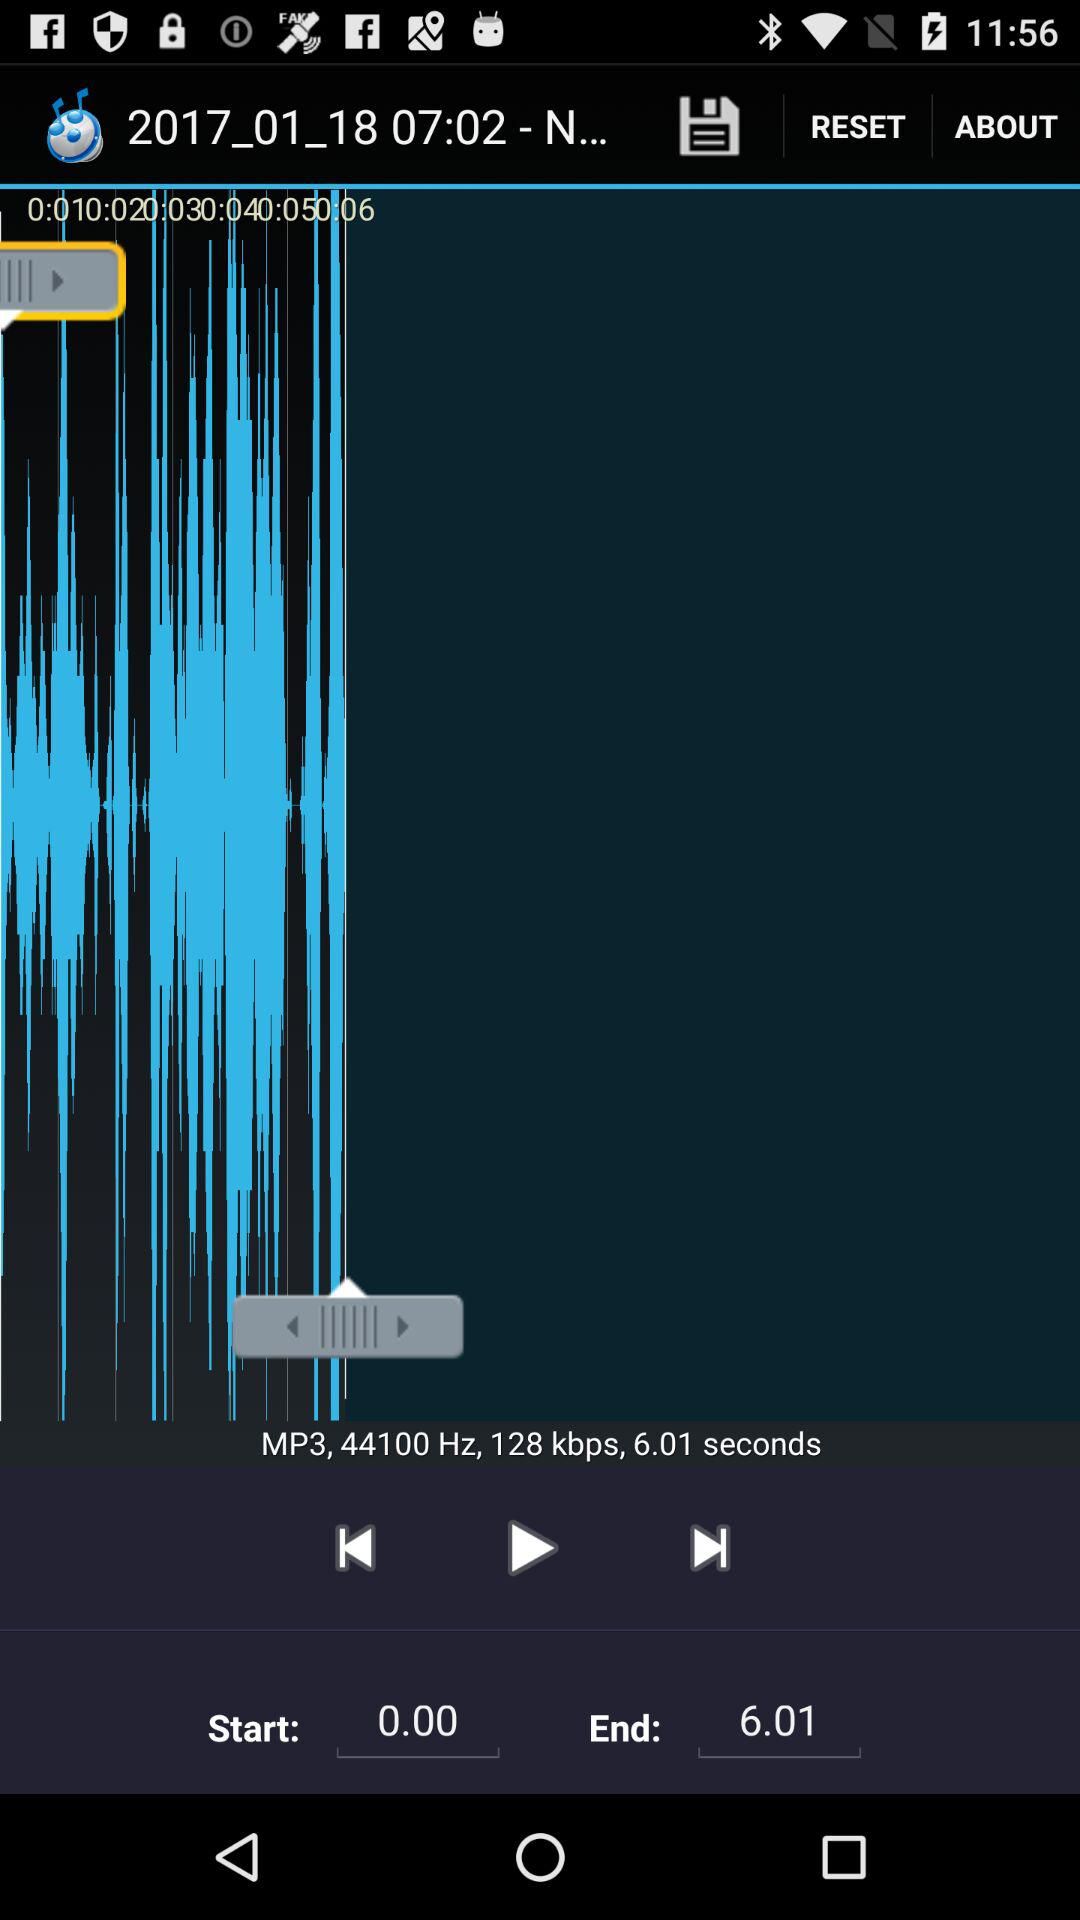What is the start time? The start time is 0.00. 